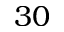Convert formula to latex. <formula><loc_0><loc_0><loc_500><loc_500>3 0</formula> 